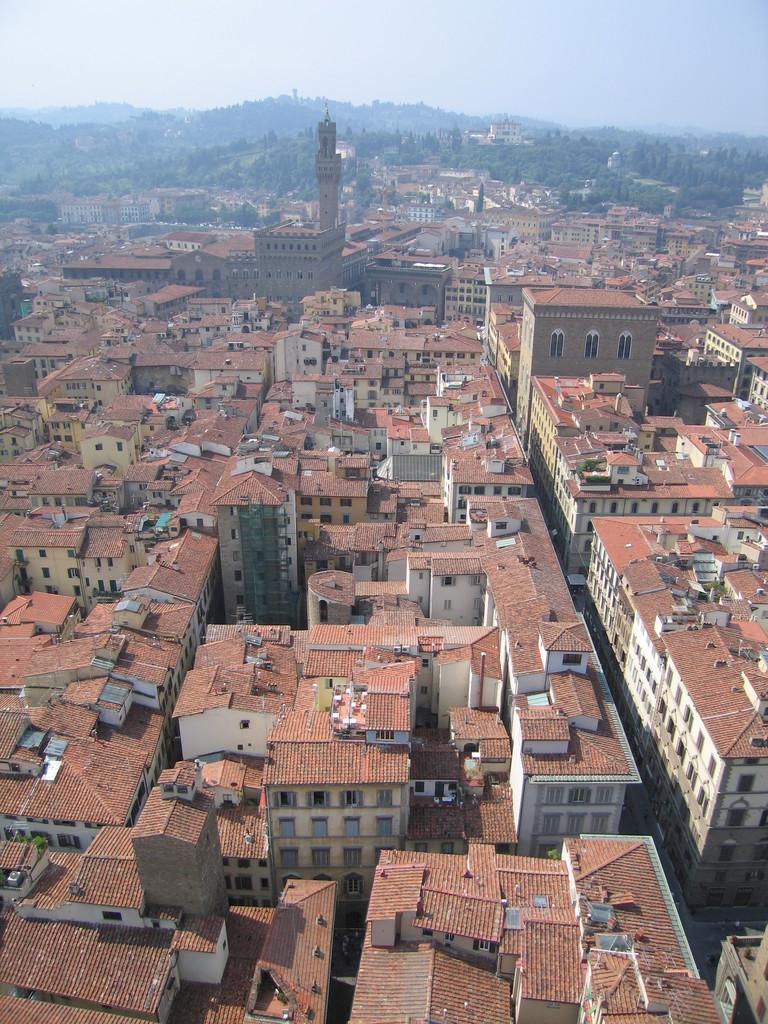Could you give a brief overview of what you see in this image? This image is a top view of a city. In the center of the image there are buildings. In the background of the image there is sky and mountains. 